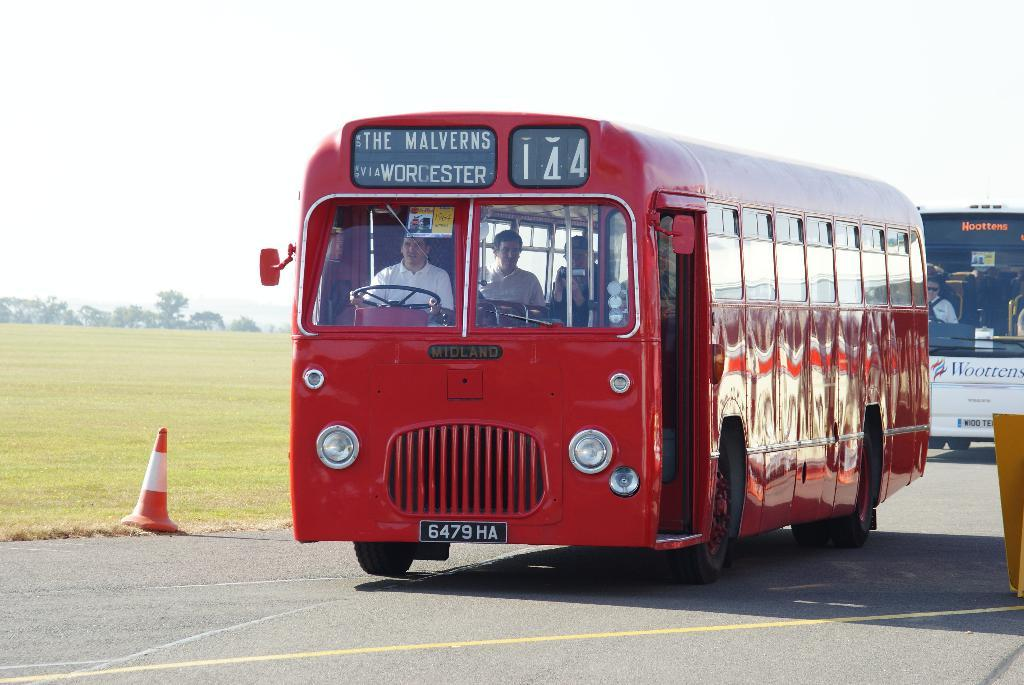<image>
Describe the image concisely. A bright red bus with a sign that reads, The Malverns via Worcester and 144. 